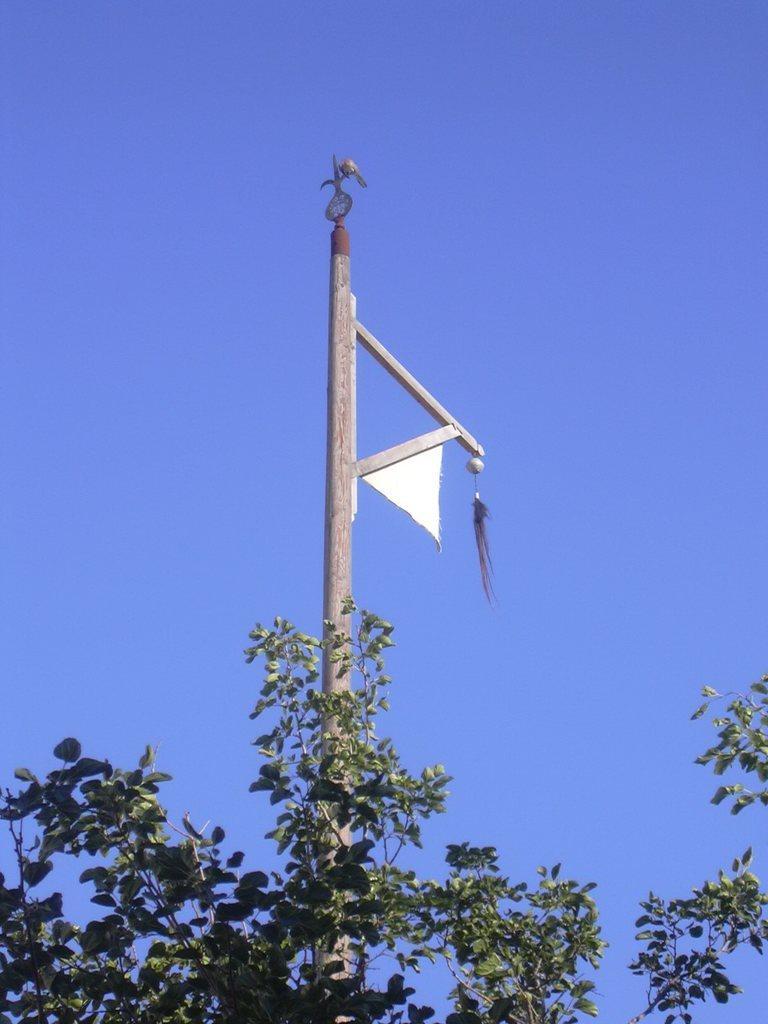In one or two sentences, can you explain what this image depicts? In the image we can see there is an iron pole and there is a cloth hanged on the pole. There is a tree and there is a clear sky. 